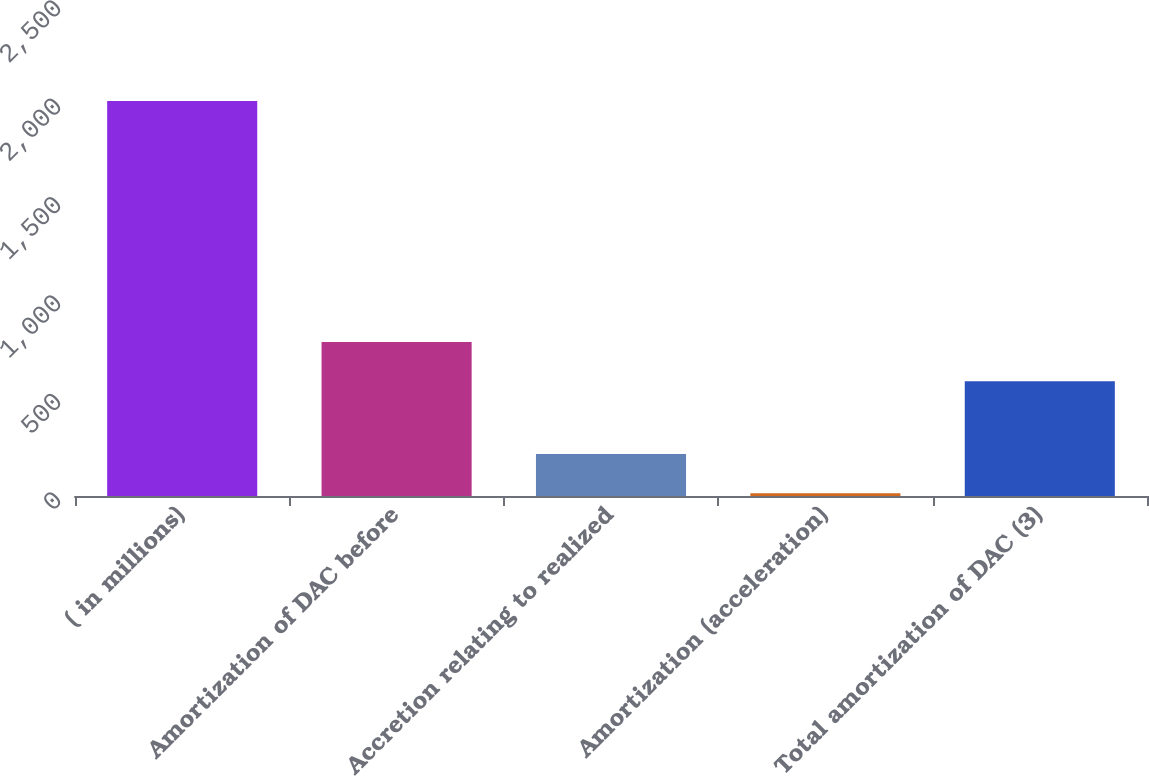<chart> <loc_0><loc_0><loc_500><loc_500><bar_chart><fcel>( in millions)<fcel>Amortization of DAC before<fcel>Accretion relating to realized<fcel>Amortization (acceleration)<fcel>Total amortization of DAC (3)<nl><fcel>2007<fcel>782.3<fcel>213.3<fcel>14<fcel>583<nl></chart> 